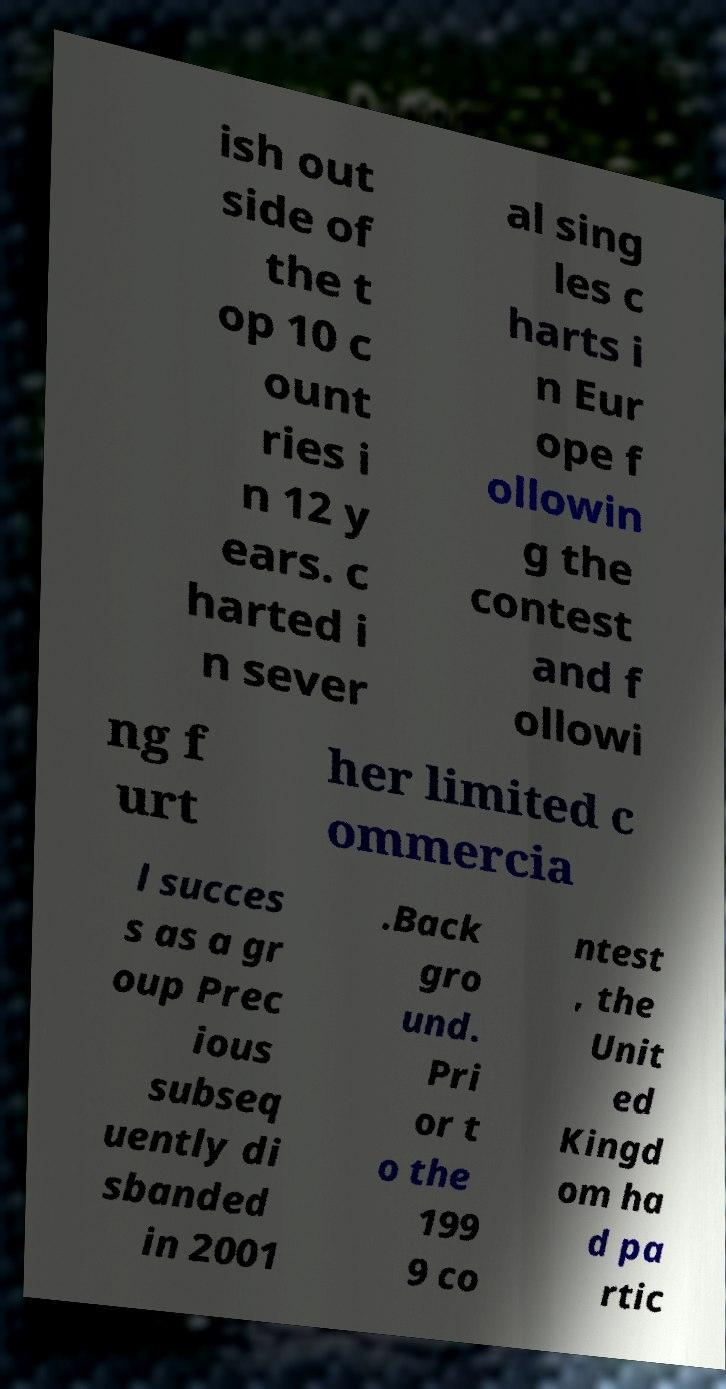There's text embedded in this image that I need extracted. Can you transcribe it verbatim? ish out side of the t op 10 c ount ries i n 12 y ears. c harted i n sever al sing les c harts i n Eur ope f ollowin g the contest and f ollowi ng f urt her limited c ommercia l succes s as a gr oup Prec ious subseq uently di sbanded in 2001 .Back gro und. Pri or t o the 199 9 co ntest , the Unit ed Kingd om ha d pa rtic 